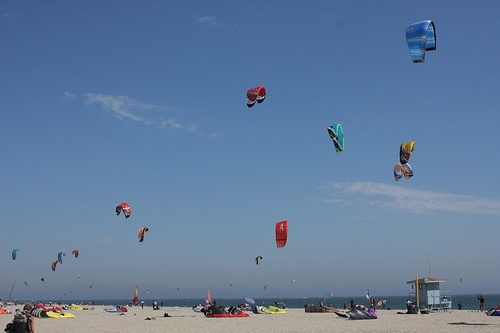Describe the objects in this image and their specific colors. I can see people in blue, gray, and darkgray tones, kite in blue, gray, and darkblue tones, people in blue, black, gray, darkgray, and brown tones, kite in blue, gray, and black tones, and kite in blue, maroon, gray, and black tones in this image. 